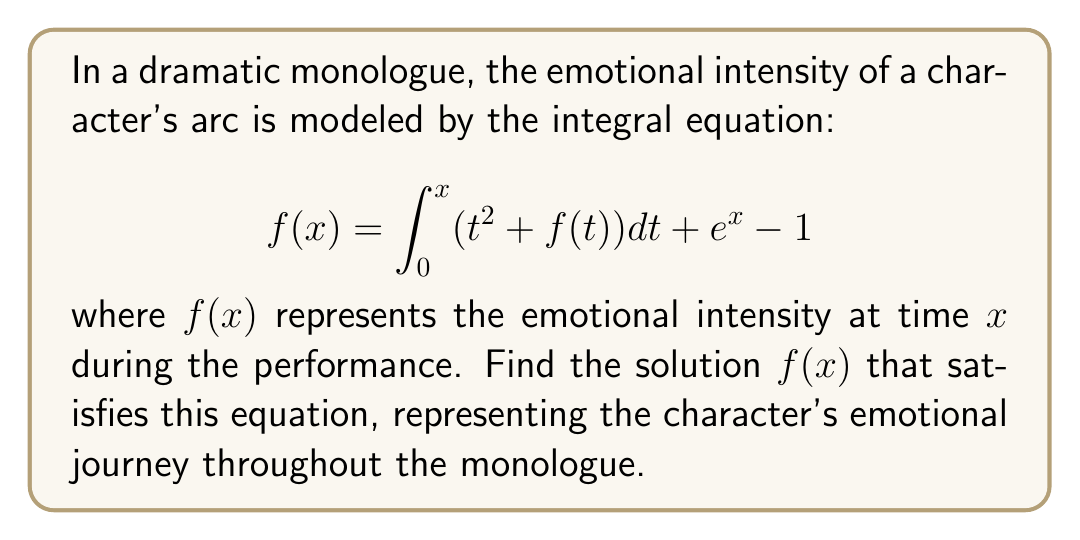Help me with this question. To solve this integral equation, we'll follow these steps:

1) First, differentiate both sides of the equation with respect to $x$:

   $$\frac{d}{dx}f(x) = \frac{d}{dx}\left[\int_0^x (t^2 + f(t)) dt + e^x - 1\right]$$

2) Using the Fundamental Theorem of Calculus and the chain rule:

   $$f'(x) = x^2 + f(x) + e^x$$

3) Rearrange the equation:

   $$f'(x) - f(x) = x^2 + e^x$$

4) This is a first-order linear differential equation of the form $y' - y = g(x)$. The general solution is:

   $$y = e^x\int e^{-x}g(x)dx + Ce^x$$

   where $C$ is a constant of integration.

5) In our case, $g(x) = x^2 + e^x$. Let's solve the integral:

   $$\int e^{-x}(x^2 + e^x)dx = \int x^2e^{-x}dx + \int dx$$

6) For $\int x^2e^{-x}dx$, use integration by parts twice:

   $$\int x^2e^{-x}dx = -x^2e^{-x} + 2xe^{-x} - 2e^{-x} + K$$

7) Combining the results:

   $$f(x) = e^x[(-x^2e^{-x} + 2xe^{-x} - 2e^{-x} + x) + C]$$

8) Simplify:

   $$f(x) = -x^2 + 2x - 2 + xe^x + Ce^x$$

9) To find $C$, use the initial condition $f(0) = 0$:

   $$0 = -0^2 + 2(0) - 2 + 0 + Ce^0$$
   $$0 = -2 + C$$
   $$C = 2$$

10) Therefore, the final solution is:

    $$f(x) = -x^2 + 2x - 2 + xe^x + 2e^x$$

This function represents the emotional intensity of the character's arc throughout the monologue.
Answer: $f(x) = -x^2 + 2x - 2 + xe^x + 2e^x$ 